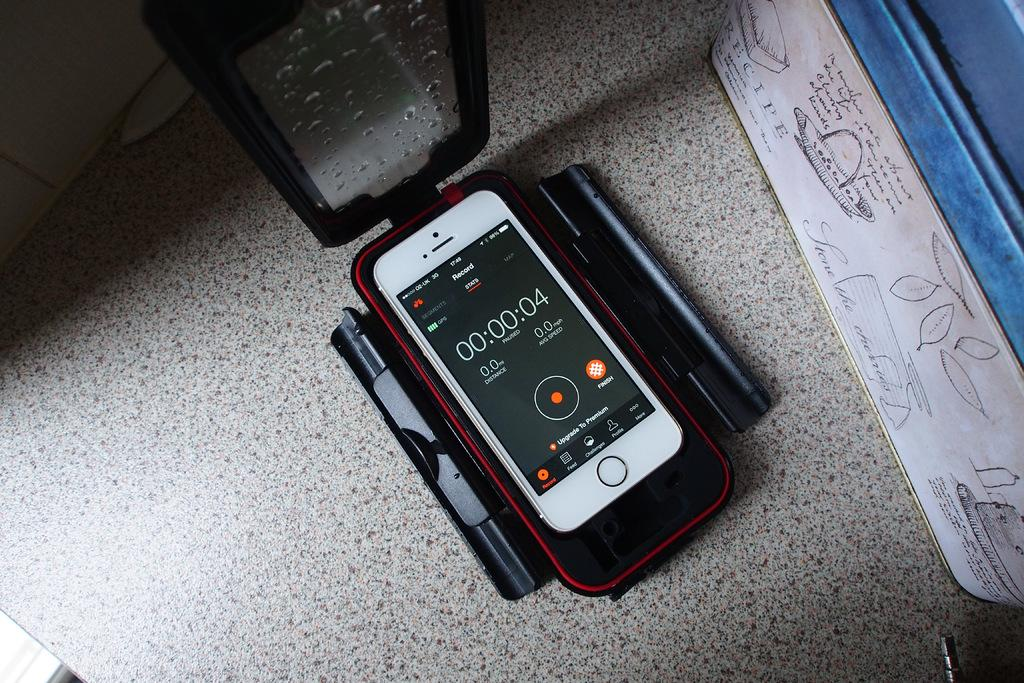<image>
Write a terse but informative summary of the picture. A smartphone screen with a timer on it that shows four seconds. 